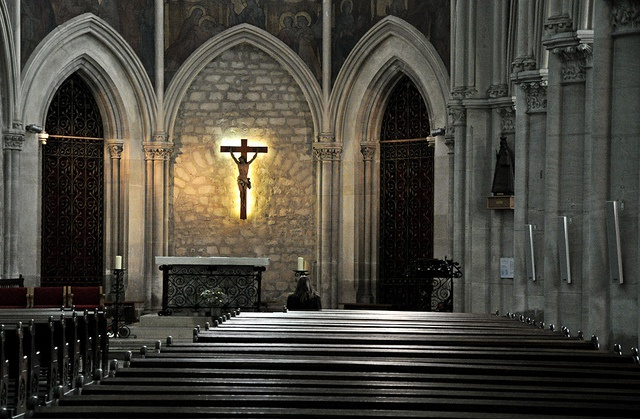Describe the objects in this image and their specific colors. I can see bench in black, gray, darkgray, and lightgray tones, bench in black and gray tones, bench in black and gray tones, bench in black, gray, and darkgray tones, and bench in black, gray, and darkgray tones in this image. 